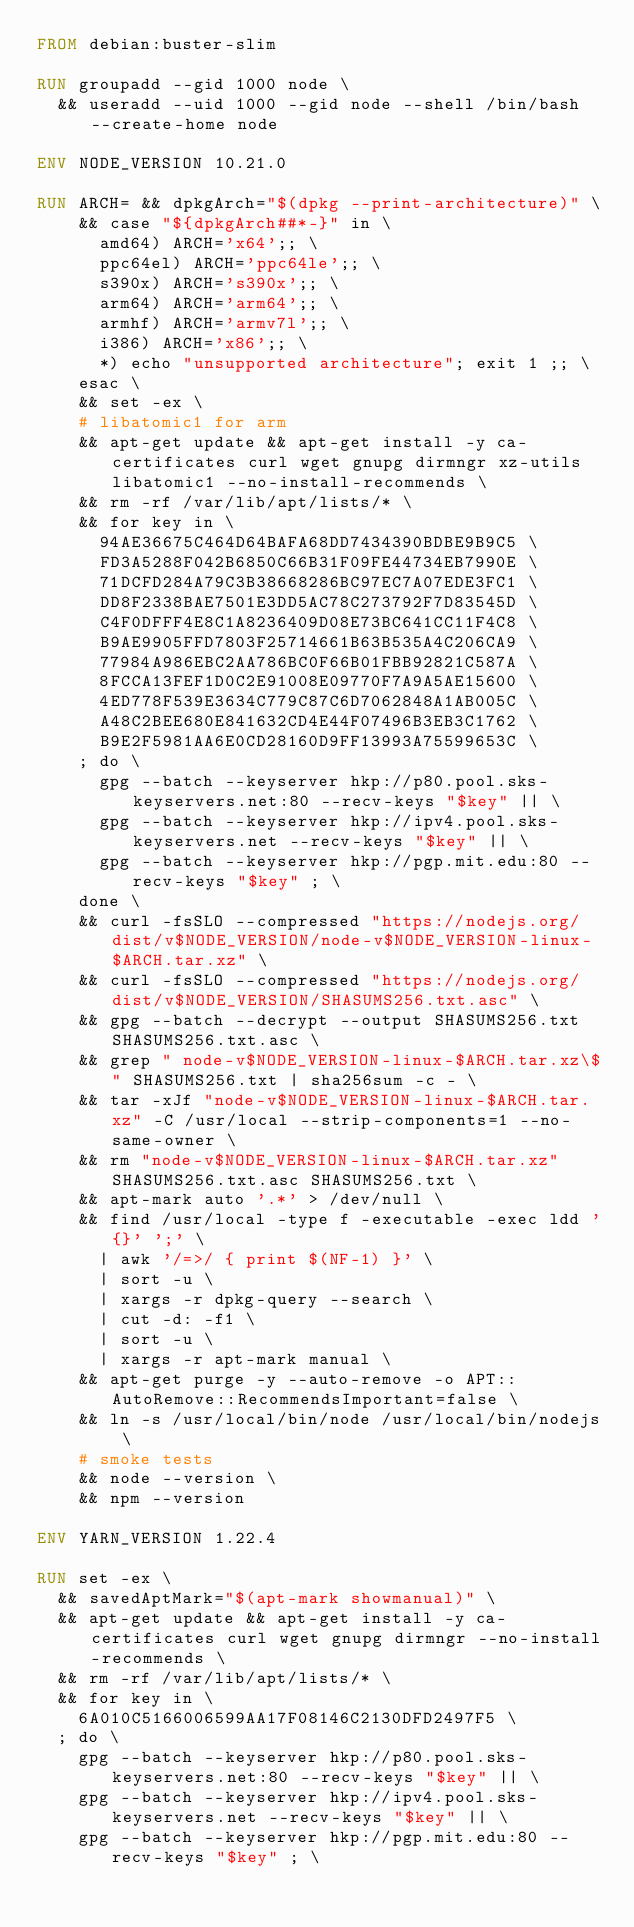<code> <loc_0><loc_0><loc_500><loc_500><_Dockerfile_>FROM debian:buster-slim

RUN groupadd --gid 1000 node \
  && useradd --uid 1000 --gid node --shell /bin/bash --create-home node

ENV NODE_VERSION 10.21.0

RUN ARCH= && dpkgArch="$(dpkg --print-architecture)" \
    && case "${dpkgArch##*-}" in \
      amd64) ARCH='x64';; \
      ppc64el) ARCH='ppc64le';; \
      s390x) ARCH='s390x';; \
      arm64) ARCH='arm64';; \
      armhf) ARCH='armv7l';; \
      i386) ARCH='x86';; \
      *) echo "unsupported architecture"; exit 1 ;; \
    esac \
    && set -ex \
    # libatomic1 for arm
    && apt-get update && apt-get install -y ca-certificates curl wget gnupg dirmngr xz-utils libatomic1 --no-install-recommends \
    && rm -rf /var/lib/apt/lists/* \
    && for key in \
      94AE36675C464D64BAFA68DD7434390BDBE9B9C5 \
      FD3A5288F042B6850C66B31F09FE44734EB7990E \
      71DCFD284A79C3B38668286BC97EC7A07EDE3FC1 \
      DD8F2338BAE7501E3DD5AC78C273792F7D83545D \
      C4F0DFFF4E8C1A8236409D08E73BC641CC11F4C8 \
      B9AE9905FFD7803F25714661B63B535A4C206CA9 \
      77984A986EBC2AA786BC0F66B01FBB92821C587A \
      8FCCA13FEF1D0C2E91008E09770F7A9A5AE15600 \
      4ED778F539E3634C779C87C6D7062848A1AB005C \
      A48C2BEE680E841632CD4E44F07496B3EB3C1762 \
      B9E2F5981AA6E0CD28160D9FF13993A75599653C \
    ; do \
      gpg --batch --keyserver hkp://p80.pool.sks-keyservers.net:80 --recv-keys "$key" || \
      gpg --batch --keyserver hkp://ipv4.pool.sks-keyservers.net --recv-keys "$key" || \
      gpg --batch --keyserver hkp://pgp.mit.edu:80 --recv-keys "$key" ; \
    done \
    && curl -fsSLO --compressed "https://nodejs.org/dist/v$NODE_VERSION/node-v$NODE_VERSION-linux-$ARCH.tar.xz" \
    && curl -fsSLO --compressed "https://nodejs.org/dist/v$NODE_VERSION/SHASUMS256.txt.asc" \
    && gpg --batch --decrypt --output SHASUMS256.txt SHASUMS256.txt.asc \
    && grep " node-v$NODE_VERSION-linux-$ARCH.tar.xz\$" SHASUMS256.txt | sha256sum -c - \
    && tar -xJf "node-v$NODE_VERSION-linux-$ARCH.tar.xz" -C /usr/local --strip-components=1 --no-same-owner \
    && rm "node-v$NODE_VERSION-linux-$ARCH.tar.xz" SHASUMS256.txt.asc SHASUMS256.txt \
    && apt-mark auto '.*' > /dev/null \
    && find /usr/local -type f -executable -exec ldd '{}' ';' \
      | awk '/=>/ { print $(NF-1) }' \
      | sort -u \
      | xargs -r dpkg-query --search \
      | cut -d: -f1 \
      | sort -u \
      | xargs -r apt-mark manual \
    && apt-get purge -y --auto-remove -o APT::AutoRemove::RecommendsImportant=false \
    && ln -s /usr/local/bin/node /usr/local/bin/nodejs \
    # smoke tests
    && node --version \
    && npm --version

ENV YARN_VERSION 1.22.4

RUN set -ex \
  && savedAptMark="$(apt-mark showmanual)" \
  && apt-get update && apt-get install -y ca-certificates curl wget gnupg dirmngr --no-install-recommends \
  && rm -rf /var/lib/apt/lists/* \
  && for key in \
    6A010C5166006599AA17F08146C2130DFD2497F5 \
  ; do \
    gpg --batch --keyserver hkp://p80.pool.sks-keyservers.net:80 --recv-keys "$key" || \
    gpg --batch --keyserver hkp://ipv4.pool.sks-keyservers.net --recv-keys "$key" || \
    gpg --batch --keyserver hkp://pgp.mit.edu:80 --recv-keys "$key" ; \</code> 